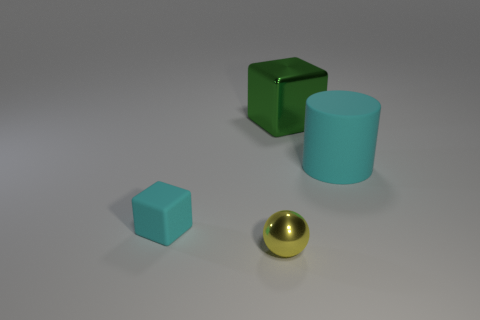What is the big cylinder made of? The large cylinder appears to have a smooth surface with light reflections similar to plastic or a rendered image. However, without being able to feel the texture or knowing the context, it is not possible to determine the material with full certainty purely from a visual analysis. 